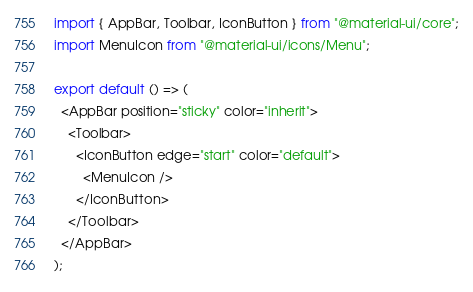<code> <loc_0><loc_0><loc_500><loc_500><_TypeScript_>import { AppBar, Toolbar, IconButton } from "@material-ui/core";
import MenuIcon from "@material-ui/icons/Menu";

export default () => (
  <AppBar position="sticky" color="inherit">
    <Toolbar>
      <IconButton edge="start" color="default">
        <MenuIcon />
      </IconButton>
    </Toolbar>
  </AppBar>
);
</code> 